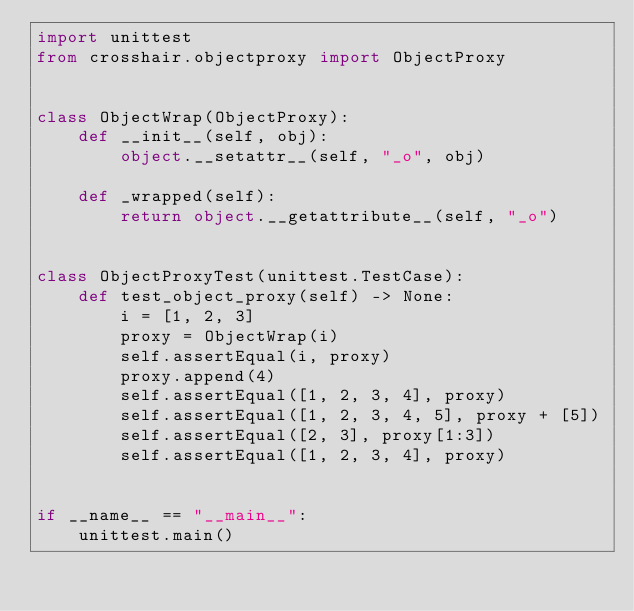<code> <loc_0><loc_0><loc_500><loc_500><_Python_>import unittest
from crosshair.objectproxy import ObjectProxy


class ObjectWrap(ObjectProxy):
    def __init__(self, obj):
        object.__setattr__(self, "_o", obj)

    def _wrapped(self):
        return object.__getattribute__(self, "_o")


class ObjectProxyTest(unittest.TestCase):
    def test_object_proxy(self) -> None:
        i = [1, 2, 3]
        proxy = ObjectWrap(i)
        self.assertEqual(i, proxy)
        proxy.append(4)
        self.assertEqual([1, 2, 3, 4], proxy)
        self.assertEqual([1, 2, 3, 4, 5], proxy + [5])
        self.assertEqual([2, 3], proxy[1:3])
        self.assertEqual([1, 2, 3, 4], proxy)


if __name__ == "__main__":
    unittest.main()
</code> 